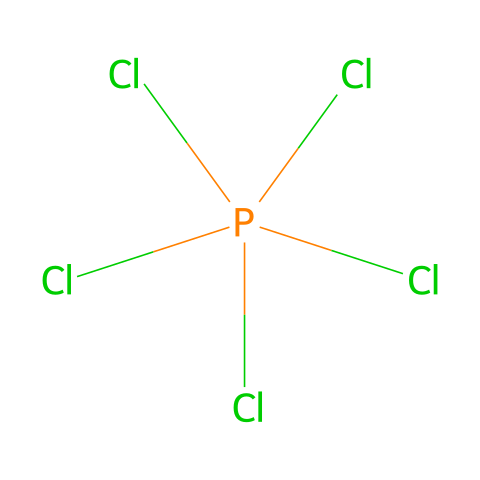What is the name of this chemical? The chemical structure shown represents phosphorus pentachloride, as indicated by the presence of one phosphorus atom (P) bonded to five chlorine atoms (Cl).
Answer: phosphorus pentachloride How many chlorine atoms are present in this compound? By examining the structure, we can count a total of five chlorine atoms attached to the central phosphorus atom.
Answer: five What is the central atom in the structure? The structure features phosphorus (P) as the central atom, bonded to multiple chlorine (Cl) atoms surrounding it.
Answer: phosphorus Does phosphorus pentachloride exhibit hypervalency? Yes, phosphorus pentachloride is hypervalent because the phosphorus atom is bonded to more than four atoms (specifically five), allowing it to expand its valence shell.
Answer: yes What is the hybridization of the phosphorus atom in this compound? The phosphorus atom in phosphorus pentachloride is typically sp3d hybridized, as it forms five bonds with surrounding chlorine atoms, involving one s orbital, three p orbitals, and one d orbital.
Answer: sp3d What is the molecular geometry of phosphorus pentachloride? The structure exhibits a trigonal bipyramidal geometry due to the arrangement of the five chlorine atoms around the phosphorus atom in two distinct axial and equatorial positions.
Answer: trigonal bipyramidal Is phosphorus pentachloride a solid at room temperature? Phosphorus pentachloride is a solid at room temperature, typically existing as a white crystalline substance.
Answer: solid 